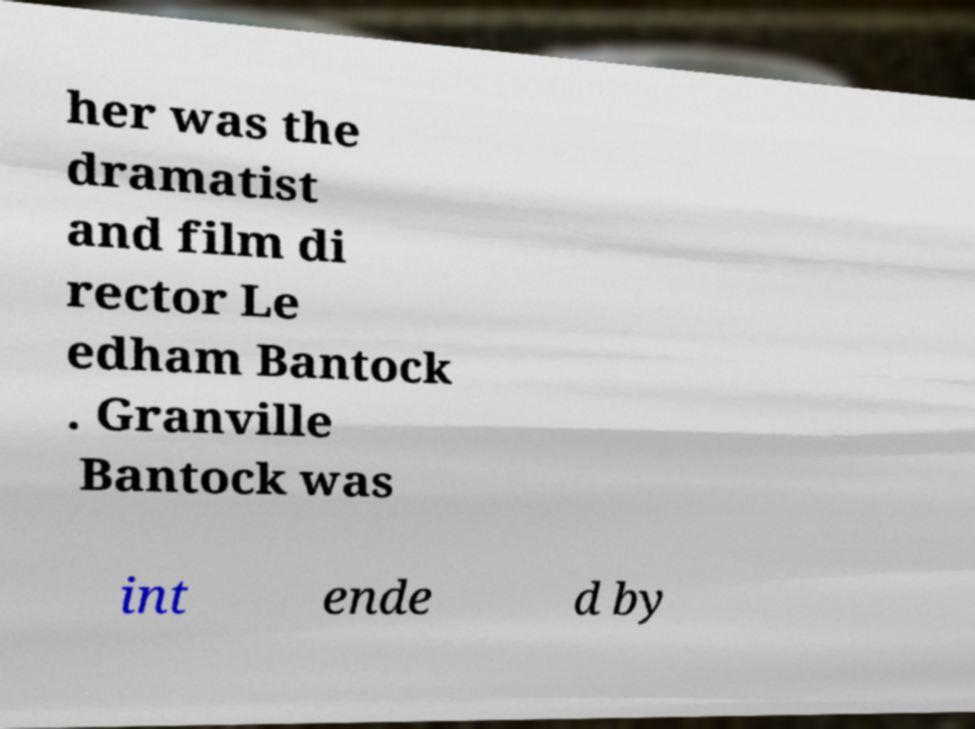What messages or text are displayed in this image? I need them in a readable, typed format. her was the dramatist and film di rector Le edham Bantock . Granville Bantock was int ende d by 